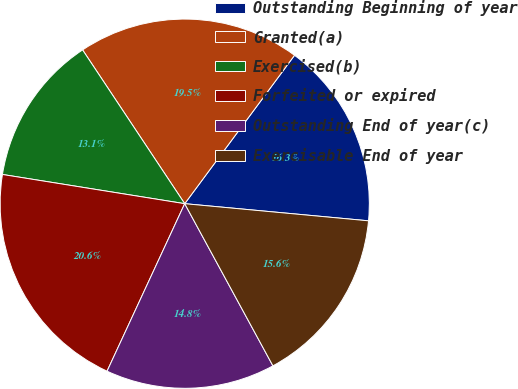Convert chart. <chart><loc_0><loc_0><loc_500><loc_500><pie_chart><fcel>Outstanding Beginning of year<fcel>Granted(a)<fcel>Exercised(b)<fcel>Forfeited or expired<fcel>Outstanding End of year(c)<fcel>Exercisable End of year<nl><fcel>16.34%<fcel>19.47%<fcel>13.14%<fcel>20.62%<fcel>14.84%<fcel>15.59%<nl></chart> 